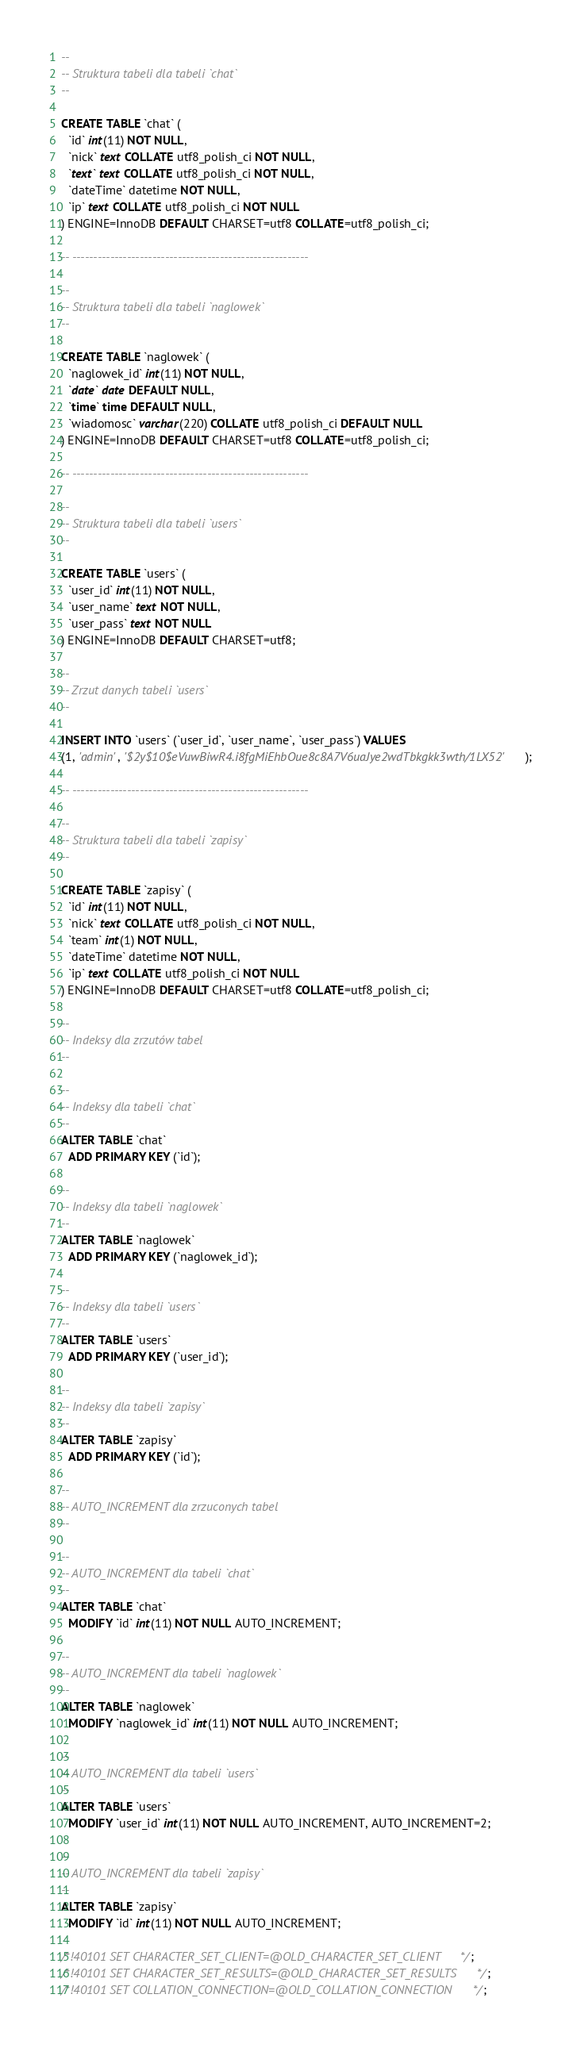Convert code to text. <code><loc_0><loc_0><loc_500><loc_500><_SQL_>
--
-- Struktura tabeli dla tabeli `chat`
--

CREATE TABLE `chat` (
  `id` int(11) NOT NULL,
  `nick` text COLLATE utf8_polish_ci NOT NULL,
  `text` text COLLATE utf8_polish_ci NOT NULL,
  `dateTime` datetime NOT NULL,
  `ip` text COLLATE utf8_polish_ci NOT NULL
) ENGINE=InnoDB DEFAULT CHARSET=utf8 COLLATE=utf8_polish_ci;

-- --------------------------------------------------------

--
-- Struktura tabeli dla tabeli `naglowek`
--

CREATE TABLE `naglowek` (
  `naglowek_id` int(11) NOT NULL,
  `date` date DEFAULT NULL,
  `time` time DEFAULT NULL,
  `wiadomosc` varchar(220) COLLATE utf8_polish_ci DEFAULT NULL
) ENGINE=InnoDB DEFAULT CHARSET=utf8 COLLATE=utf8_polish_ci;

-- --------------------------------------------------------

--
-- Struktura tabeli dla tabeli `users`
--

CREATE TABLE `users` (
  `user_id` int(11) NOT NULL,
  `user_name` text NOT NULL,
  `user_pass` text NOT NULL
) ENGINE=InnoDB DEFAULT CHARSET=utf8;

--
-- Zrzut danych tabeli `users`
--

INSERT INTO `users` (`user_id`, `user_name`, `user_pass`) VALUES
(1, 'admin', '$2y$10$eVuwBiwR4.i8fgMiEhbOue8c8A7V6uaJye2wdTbkgkk3wth/1LX52');

-- --------------------------------------------------------

--
-- Struktura tabeli dla tabeli `zapisy`
--

CREATE TABLE `zapisy` (
  `id` int(11) NOT NULL,
  `nick` text COLLATE utf8_polish_ci NOT NULL,
  `team` int(1) NOT NULL,
  `dateTime` datetime NOT NULL,
  `ip` text COLLATE utf8_polish_ci NOT NULL
) ENGINE=InnoDB DEFAULT CHARSET=utf8 COLLATE=utf8_polish_ci;

--
-- Indeksy dla zrzutów tabel
--

--
-- Indeksy dla tabeli `chat`
--
ALTER TABLE `chat`
  ADD PRIMARY KEY (`id`);

--
-- Indeksy dla tabeli `naglowek`
--
ALTER TABLE `naglowek`
  ADD PRIMARY KEY (`naglowek_id`);

--
-- Indeksy dla tabeli `users`
--
ALTER TABLE `users`
  ADD PRIMARY KEY (`user_id`);

--
-- Indeksy dla tabeli `zapisy`
--
ALTER TABLE `zapisy`
  ADD PRIMARY KEY (`id`);

--
-- AUTO_INCREMENT dla zrzuconych tabel
--

--
-- AUTO_INCREMENT dla tabeli `chat`
--
ALTER TABLE `chat`
  MODIFY `id` int(11) NOT NULL AUTO_INCREMENT;

--
-- AUTO_INCREMENT dla tabeli `naglowek`
--
ALTER TABLE `naglowek`
  MODIFY `naglowek_id` int(11) NOT NULL AUTO_INCREMENT;

--
-- AUTO_INCREMENT dla tabeli `users`
--
ALTER TABLE `users`
  MODIFY `user_id` int(11) NOT NULL AUTO_INCREMENT, AUTO_INCREMENT=2;

--
-- AUTO_INCREMENT dla tabeli `zapisy`
--
ALTER TABLE `zapisy`
  MODIFY `id` int(11) NOT NULL AUTO_INCREMENT;

/*!40101 SET CHARACTER_SET_CLIENT=@OLD_CHARACTER_SET_CLIENT */;
/*!40101 SET CHARACTER_SET_RESULTS=@OLD_CHARACTER_SET_RESULTS */;
/*!40101 SET COLLATION_CONNECTION=@OLD_COLLATION_CONNECTION */;
</code> 